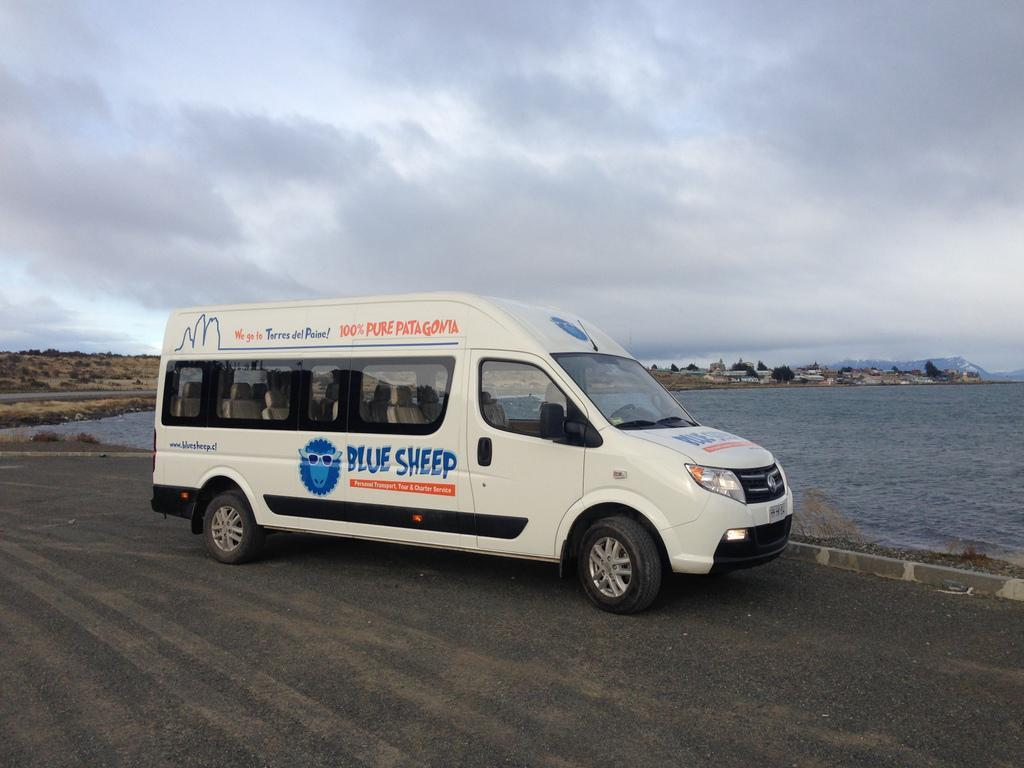Provide a one-sentence caption for the provided image. A passenger van that reads, "Blue Sheep" sits on a road next to water. 